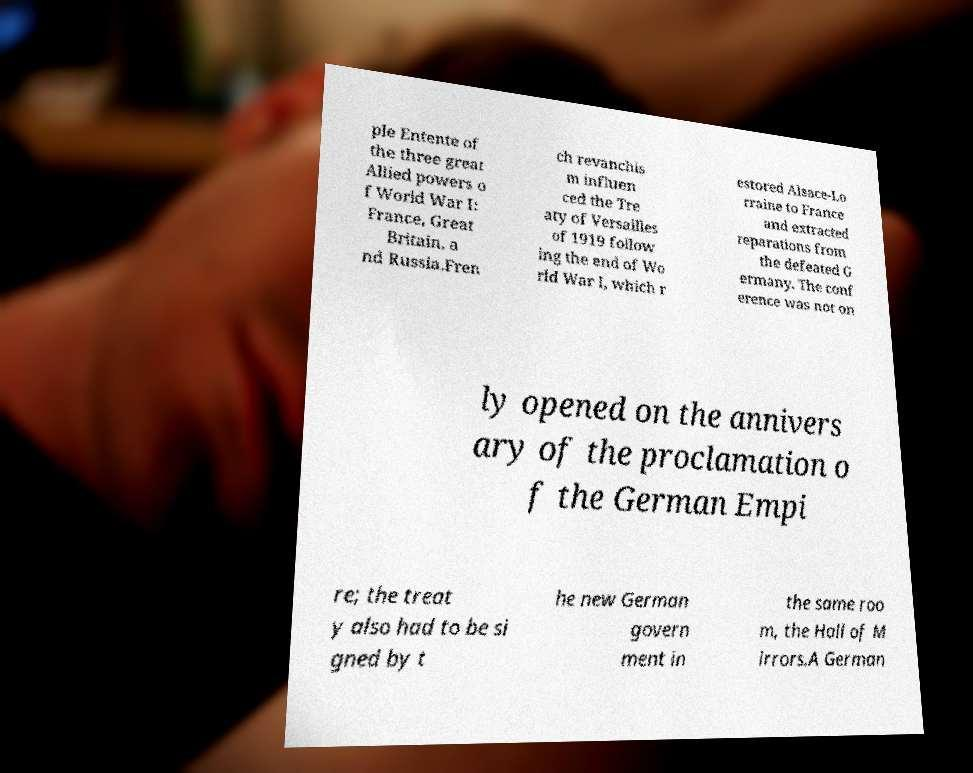Can you accurately transcribe the text from the provided image for me? ple Entente of the three great Allied powers o f World War I: France, Great Britain, a nd Russia.Fren ch revanchis m influen ced the Tre aty of Versailles of 1919 follow ing the end of Wo rld War I, which r estored Alsace-Lo rraine to France and extracted reparations from the defeated G ermany. The conf erence was not on ly opened on the annivers ary of the proclamation o f the German Empi re; the treat y also had to be si gned by t he new German govern ment in the same roo m, the Hall of M irrors.A German 